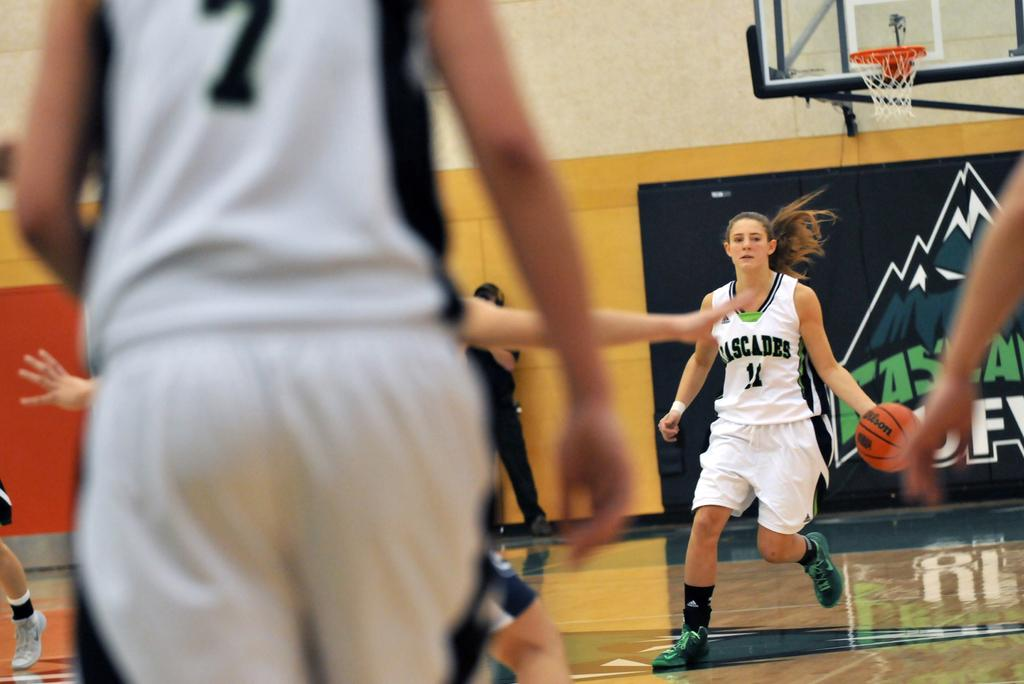<image>
Create a compact narrative representing the image presented. a lady bouncing a Wilson ball during the game 